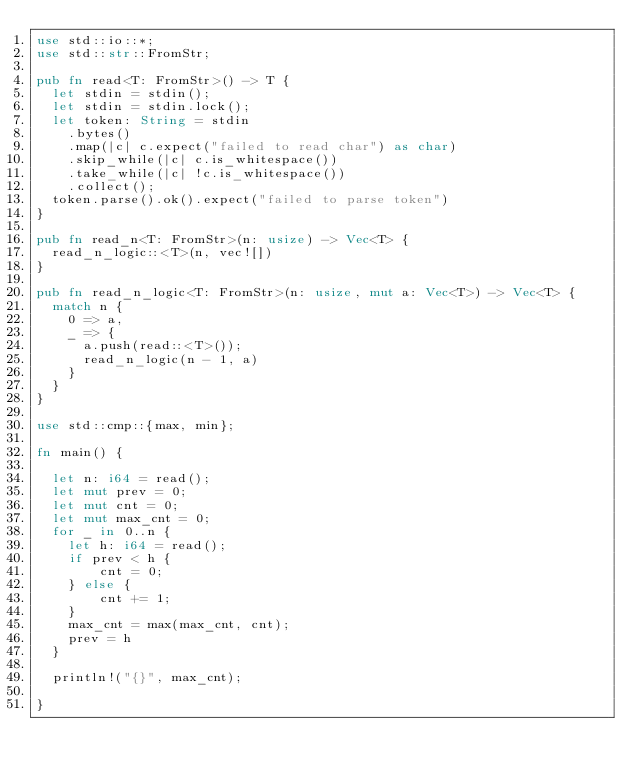Convert code to text. <code><loc_0><loc_0><loc_500><loc_500><_Rust_>use std::io::*;
use std::str::FromStr;

pub fn read<T: FromStr>() -> T {
  let stdin = stdin();
  let stdin = stdin.lock();
  let token: String = stdin
    .bytes()
    .map(|c| c.expect("failed to read char") as char)
    .skip_while(|c| c.is_whitespace())
    .take_while(|c| !c.is_whitespace())
    .collect();
  token.parse().ok().expect("failed to parse token")
}

pub fn read_n<T: FromStr>(n: usize) -> Vec<T> {
  read_n_logic::<T>(n, vec![])
}

pub fn read_n_logic<T: FromStr>(n: usize, mut a: Vec<T>) -> Vec<T> {
  match n {
    0 => a,
    _ => {
      a.push(read::<T>());
      read_n_logic(n - 1, a)
    }
  }
}

use std::cmp::{max, min};

fn main() {

  let n: i64 = read();
  let mut prev = 0;
  let mut cnt = 0;
  let mut max_cnt = 0;
  for _ in 0..n {
    let h: i64 = read();
    if prev < h {
        cnt = 0;
    } else {
        cnt += 1;
    }
    max_cnt = max(max_cnt, cnt);
    prev = h
  }

  println!("{}", max_cnt);
  
}
</code> 